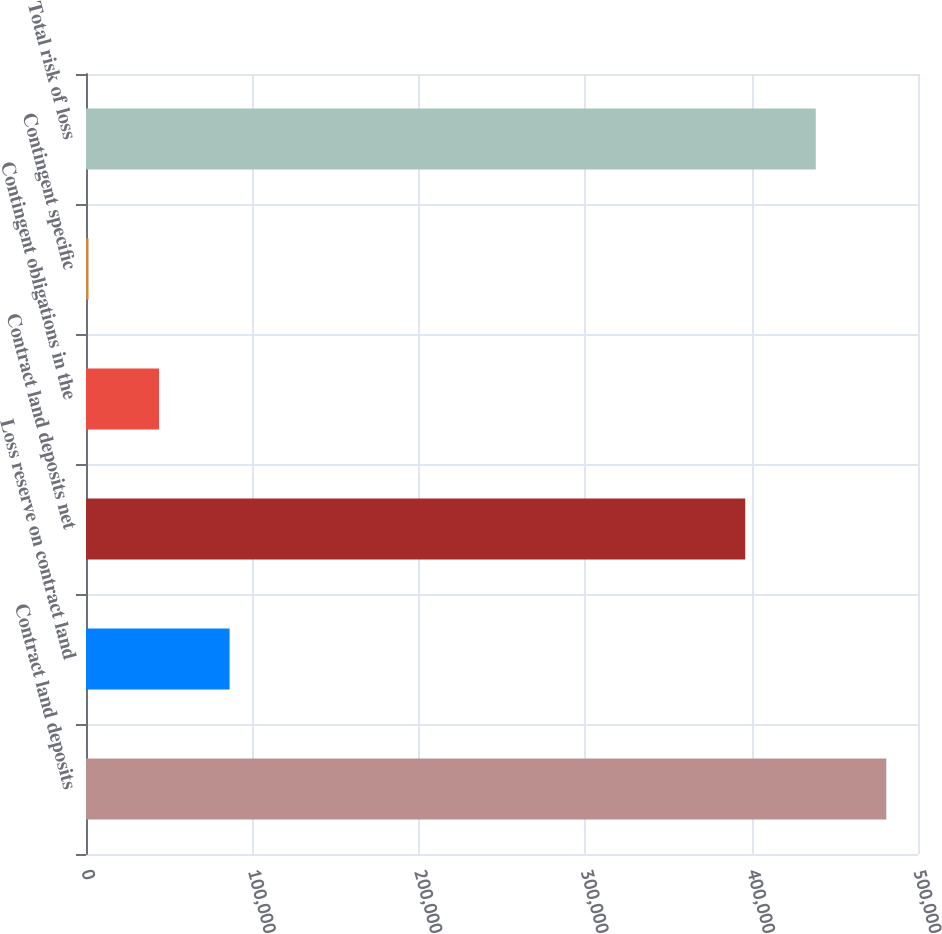Convert chart. <chart><loc_0><loc_0><loc_500><loc_500><bar_chart><fcel>Contract land deposits<fcel>Loss reserve on contract land<fcel>Contract land deposits net<fcel>Contingent obligations in the<fcel>Contingent specific<fcel>Total risk of loss<nl><fcel>480955<fcel>86282.6<fcel>396177<fcel>43893.8<fcel>1505<fcel>438566<nl></chart> 